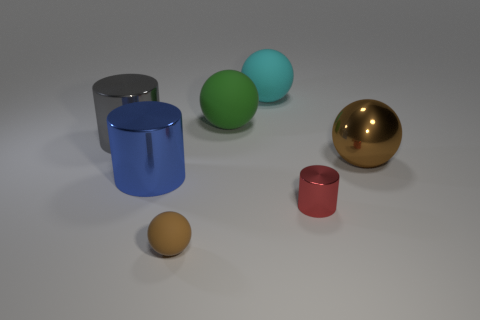Subtract all large cylinders. How many cylinders are left? 1 Subtract all blue cubes. How many brown spheres are left? 2 Subtract all cyan balls. How many balls are left? 3 Subtract 2 spheres. How many spheres are left? 2 Add 1 small gray metal blocks. How many objects exist? 8 Subtract all cylinders. How many objects are left? 4 Subtract all green cylinders. Subtract all brown spheres. How many cylinders are left? 3 Subtract all blue matte balls. Subtract all blue metal cylinders. How many objects are left? 6 Add 5 gray cylinders. How many gray cylinders are left? 6 Add 5 small purple shiny balls. How many small purple shiny balls exist? 5 